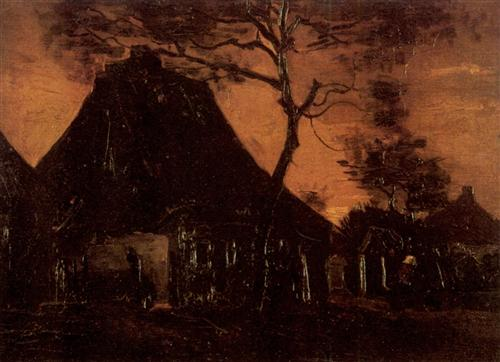Can you describe the mood of the painting and what elements contribute to it? The mood of the painting is quite somber and eerie. Various elements contribute to this overall feeling: the dark, twisted tree in the foreground, the imposing but abandoned cottage with its thatched roof, and the dark orange hue of the sky that hints at dusk or dawn. The lack of human presence and the detailed decay add to the painting’s desolate vibe. The artist skillfully uses these elements to evoke a haunting and melancholic atmosphere, suggesting a story of abandonment and forgotten times. 